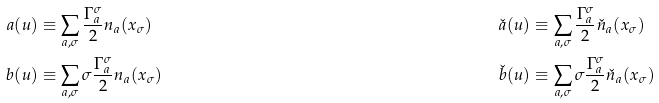<formula> <loc_0><loc_0><loc_500><loc_500>a ( u ) & \equiv \sum _ { a , \sigma } \frac { \Gamma ^ { \sigma } _ { a } } { 2 } n _ { a } ( x _ { \sigma } ) & \check { a } ( u ) & \equiv \sum _ { a , \sigma } \frac { \Gamma ^ { \sigma } _ { a } } { 2 } \check { n } _ { a } ( x _ { \sigma } ) & \\ b ( u ) & \equiv \sum _ { a , \sigma } \sigma \frac { \Gamma ^ { \sigma } _ { a } } { 2 } n _ { a } ( x _ { \sigma } ) & \check { b } ( u ) & \equiv \sum _ { a , \sigma } \sigma \frac { \Gamma ^ { \sigma } _ { a } } { 2 } \check { n } _ { a } ( x _ { \sigma } ) &</formula> 